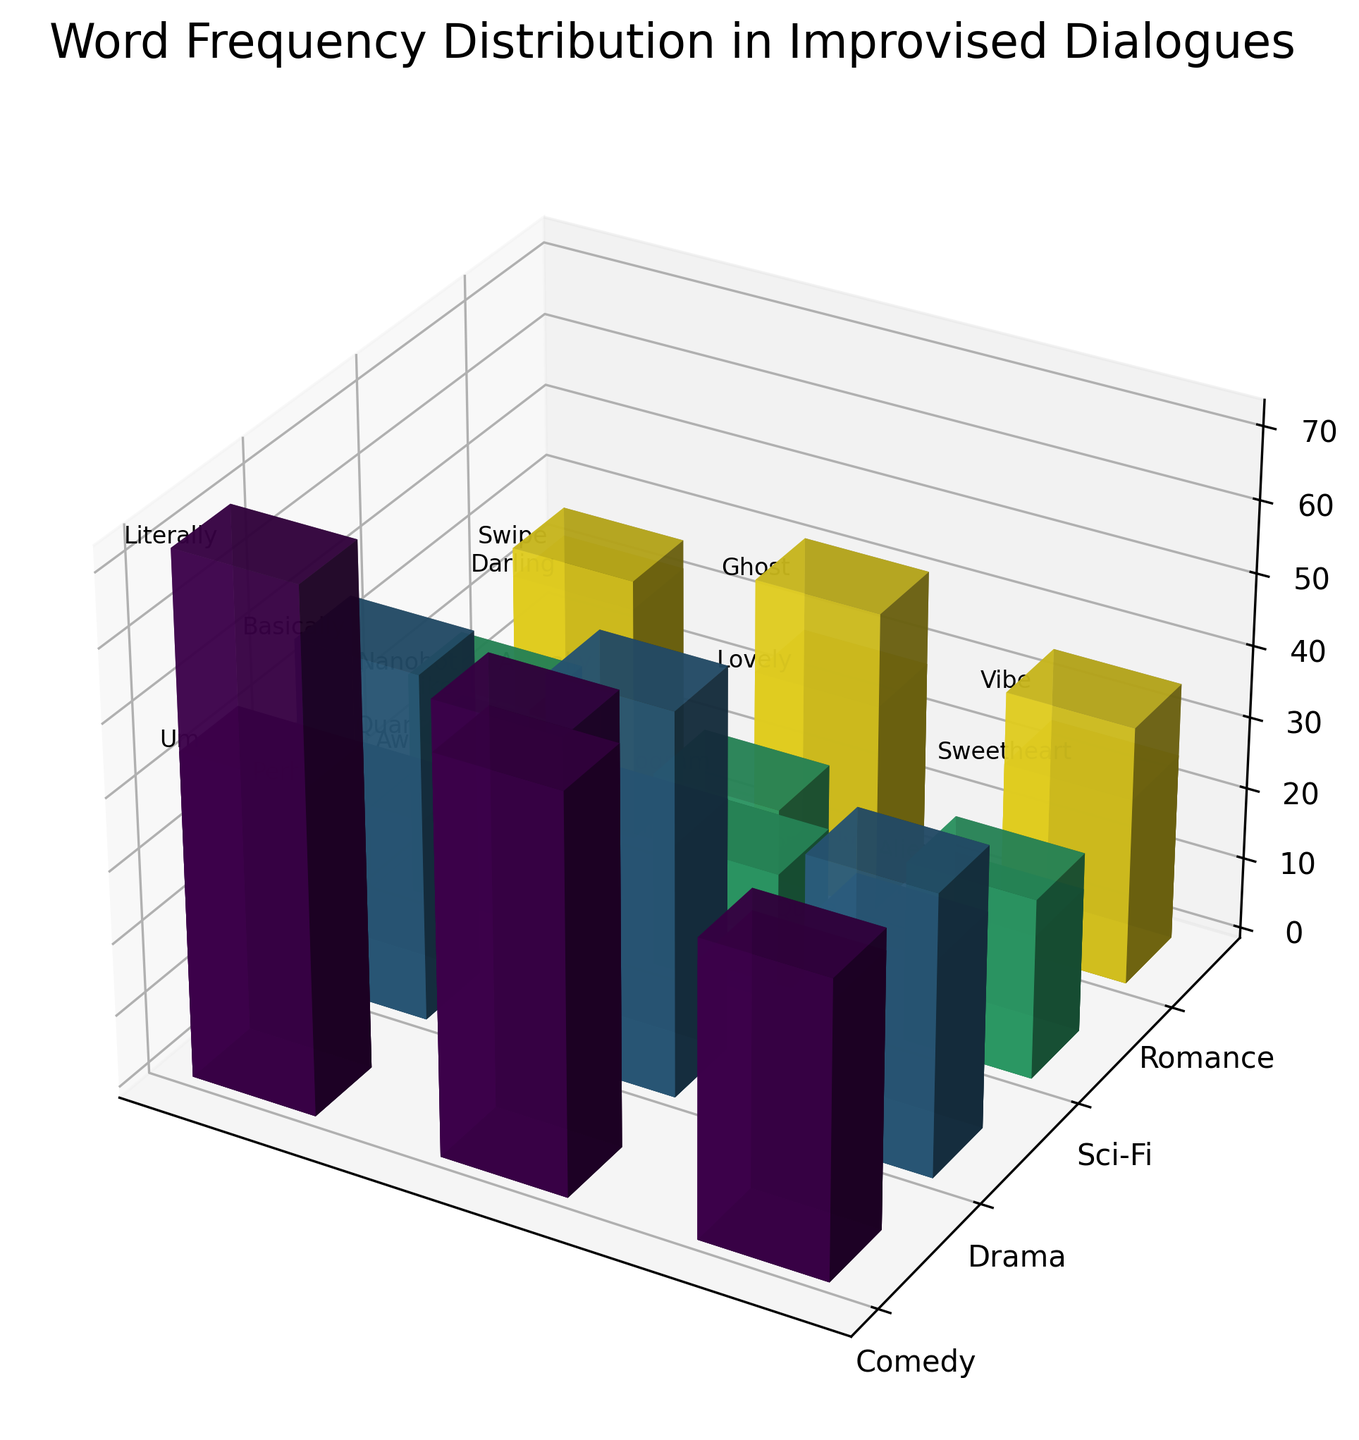what's the title of the figure? Look at the text displayed on the top of the plot, usually centered and in a larger font size for the title. Here, it says "Word Frequency Distribution in Improvised Dialogues".
Answer: Word Frequency Distribution in Improvised Dialogues Which genre appears at the bottom on the y-axis? The y-axis lists the genres. The genre listed furthest to the bottom is "Romance".
Answer: Romance How many time periods are used in the plot? The legend on the right side of the plot shows different time periods. Counting these, we have four: 1970s, 1980s, 1990s, 2000s, 2010s, 2020s, 2030s.
Answer: 7 Which word has the highest frequency in the plot? To find this, you need to locate the tallest bar along the z-axis. The tallest bar corresponds to the word "Literally" in Comedy, 2010s with a frequency of 72.
Answer: Literally Between the Drama genre in the 1990s and 2020s, which genre uses more words overall? Sum the frequencies of the words for Drama in both time periods. In the 1990s, frequencies are: 28 + 35 + 30 = 93. In the 2020s, frequencies are: 48 + 53 + 39 = 140. Thus, the 2020s have a higher cumulative frequency.
Answer: 2020s Which genre has the most diverse vocabulary across all time periods in terms of unique words? Count the unique words for each genre listed in the plot. Comedy and Drama each have 6 unique words across their respective time periods, while Sci-Fi and Romance also have 6 unique words respectively. Thus, all genres are equal in this respect.
Answer: All genres In Sci-Fi during the 2030s, which word has the lowest frequency? Look at the bars for Sci-Fi in the 2030s and note their heights. The word "Hyperspace" has the lowest frequency, which is 20.
Answer: Hyperspace Compare the frequency of the word "Awesome" in Comedy (2010s) with the word "Indeed" in Drama (1990s), which is higher? Check the bar heights for "Awesome" in Comedy (2010s) and "Indeed" in Drama (1990s). "Awesome" has a frequency of 55, which is higher than "Indeed" with a frequency of 35.
Answer: Awesome In which genre and time period is the word "Darling" found, and what is its frequency? The word "Darling" is found in the Romance genre in the 1970s with a frequency of 33.
Answer: Romance, 1970s, 33 Which genre uses more filler words like "Um" and "Yeah" in the 1980s? Sum the frequencies of "Um" and "Yeah" in the Comedy genre for the 1980s, which are 45 and 38 respectively, totaling 83. Drama does not have similar words in this time period. So, Comedy uses more filler words.
Answer: Comedy 